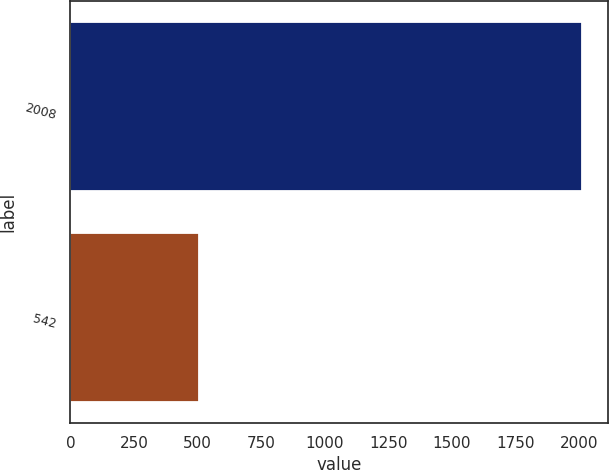Convert chart. <chart><loc_0><loc_0><loc_500><loc_500><bar_chart><fcel>2008<fcel>542<nl><fcel>2012<fcel>504<nl></chart> 